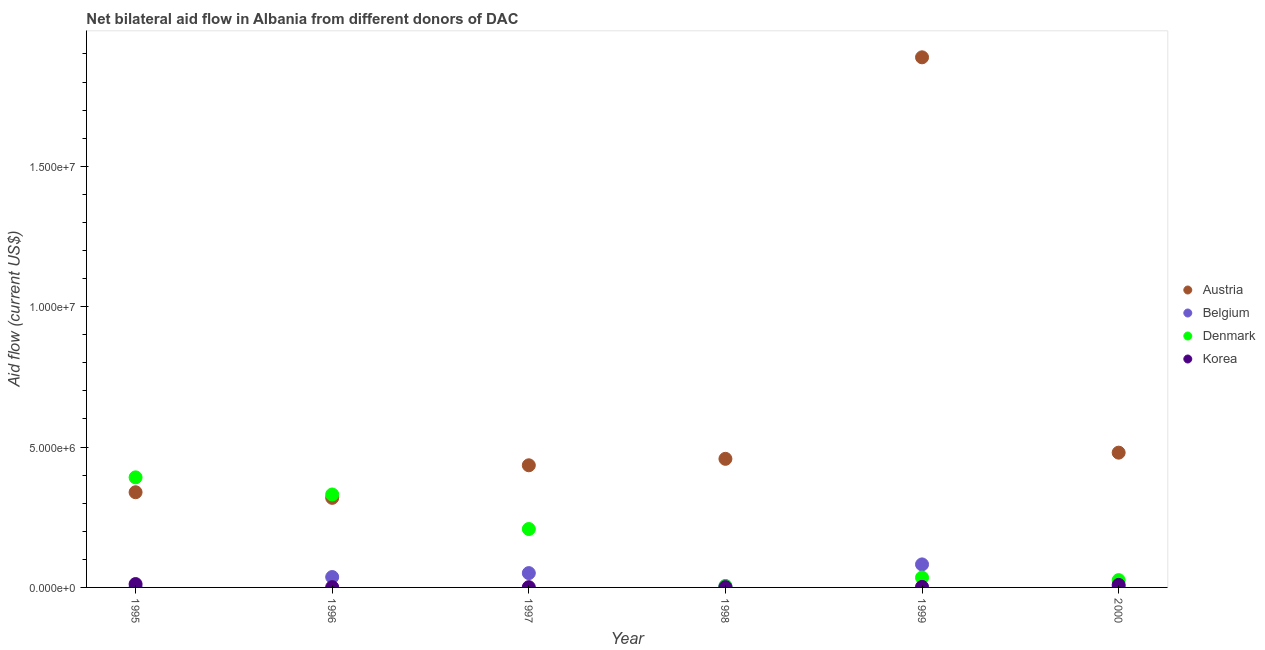Is the number of dotlines equal to the number of legend labels?
Keep it short and to the point. Yes. What is the amount of aid given by austria in 1996?
Your response must be concise. 3.19e+06. Across all years, what is the maximum amount of aid given by korea?
Your response must be concise. 1.20e+05. Across all years, what is the minimum amount of aid given by korea?
Keep it short and to the point. 10000. In which year was the amount of aid given by denmark minimum?
Your answer should be very brief. 1998. What is the total amount of aid given by denmark in the graph?
Keep it short and to the point. 9.95e+06. What is the difference between the amount of aid given by belgium in 1995 and that in 1996?
Provide a succinct answer. -3.60e+05. What is the difference between the amount of aid given by korea in 1998 and the amount of aid given by belgium in 1995?
Offer a terse response. 0. What is the average amount of aid given by denmark per year?
Offer a terse response. 1.66e+06. In the year 1997, what is the difference between the amount of aid given by austria and amount of aid given by belgium?
Offer a very short reply. 3.84e+06. In how many years, is the amount of aid given by austria greater than 8000000 US$?
Offer a terse response. 1. What is the ratio of the amount of aid given by korea in 1995 to that in 1999?
Ensure brevity in your answer.  6. What is the difference between the highest and the lowest amount of aid given by denmark?
Give a very brief answer. 3.89e+06. Is it the case that in every year, the sum of the amount of aid given by austria and amount of aid given by belgium is greater than the amount of aid given by denmark?
Make the answer very short. No. Does the amount of aid given by korea monotonically increase over the years?
Offer a very short reply. No. Is the amount of aid given by korea strictly less than the amount of aid given by belgium over the years?
Offer a terse response. No. How many dotlines are there?
Ensure brevity in your answer.  4. Does the graph contain any zero values?
Provide a succinct answer. No. Does the graph contain grids?
Provide a short and direct response. No. What is the title of the graph?
Your response must be concise. Net bilateral aid flow in Albania from different donors of DAC. What is the label or title of the Y-axis?
Offer a very short reply. Aid flow (current US$). What is the Aid flow (current US$) of Austria in 1995?
Ensure brevity in your answer.  3.39e+06. What is the Aid flow (current US$) in Denmark in 1995?
Offer a terse response. 3.92e+06. What is the Aid flow (current US$) of Korea in 1995?
Keep it short and to the point. 1.20e+05. What is the Aid flow (current US$) in Austria in 1996?
Provide a succinct answer. 3.19e+06. What is the Aid flow (current US$) in Belgium in 1996?
Provide a succinct answer. 3.70e+05. What is the Aid flow (current US$) of Denmark in 1996?
Ensure brevity in your answer.  3.31e+06. What is the Aid flow (current US$) in Austria in 1997?
Make the answer very short. 4.35e+06. What is the Aid flow (current US$) in Belgium in 1997?
Provide a short and direct response. 5.10e+05. What is the Aid flow (current US$) in Denmark in 1997?
Offer a very short reply. 2.08e+06. What is the Aid flow (current US$) of Austria in 1998?
Provide a succinct answer. 4.58e+06. What is the Aid flow (current US$) of Denmark in 1998?
Keep it short and to the point. 3.00e+04. What is the Aid flow (current US$) of Austria in 1999?
Ensure brevity in your answer.  1.89e+07. What is the Aid flow (current US$) in Belgium in 1999?
Keep it short and to the point. 8.20e+05. What is the Aid flow (current US$) of Denmark in 1999?
Give a very brief answer. 3.50e+05. What is the Aid flow (current US$) of Austria in 2000?
Give a very brief answer. 4.80e+06. What is the Aid flow (current US$) of Belgium in 2000?
Make the answer very short. 10000. Across all years, what is the maximum Aid flow (current US$) of Austria?
Your answer should be compact. 1.89e+07. Across all years, what is the maximum Aid flow (current US$) in Belgium?
Ensure brevity in your answer.  8.20e+05. Across all years, what is the maximum Aid flow (current US$) of Denmark?
Make the answer very short. 3.92e+06. Across all years, what is the maximum Aid flow (current US$) in Korea?
Ensure brevity in your answer.  1.20e+05. Across all years, what is the minimum Aid flow (current US$) of Austria?
Make the answer very short. 3.19e+06. Across all years, what is the minimum Aid flow (current US$) of Belgium?
Your answer should be compact. 10000. Across all years, what is the minimum Aid flow (current US$) of Denmark?
Make the answer very short. 3.00e+04. What is the total Aid flow (current US$) of Austria in the graph?
Provide a short and direct response. 3.92e+07. What is the total Aid flow (current US$) of Belgium in the graph?
Ensure brevity in your answer.  1.77e+06. What is the total Aid flow (current US$) in Denmark in the graph?
Make the answer very short. 9.95e+06. What is the total Aid flow (current US$) in Korea in the graph?
Offer a very short reply. 2.60e+05. What is the difference between the Aid flow (current US$) in Belgium in 1995 and that in 1996?
Your answer should be very brief. -3.60e+05. What is the difference between the Aid flow (current US$) in Denmark in 1995 and that in 1996?
Offer a terse response. 6.10e+05. What is the difference between the Aid flow (current US$) of Korea in 1995 and that in 1996?
Offer a very short reply. 1.10e+05. What is the difference between the Aid flow (current US$) of Austria in 1995 and that in 1997?
Offer a terse response. -9.60e+05. What is the difference between the Aid flow (current US$) in Belgium in 1995 and that in 1997?
Ensure brevity in your answer.  -5.00e+05. What is the difference between the Aid flow (current US$) in Denmark in 1995 and that in 1997?
Your answer should be compact. 1.84e+06. What is the difference between the Aid flow (current US$) in Korea in 1995 and that in 1997?
Your answer should be compact. 1.10e+05. What is the difference between the Aid flow (current US$) of Austria in 1995 and that in 1998?
Give a very brief answer. -1.19e+06. What is the difference between the Aid flow (current US$) in Denmark in 1995 and that in 1998?
Provide a short and direct response. 3.89e+06. What is the difference between the Aid flow (current US$) of Korea in 1995 and that in 1998?
Give a very brief answer. 1.10e+05. What is the difference between the Aid flow (current US$) of Austria in 1995 and that in 1999?
Your answer should be very brief. -1.55e+07. What is the difference between the Aid flow (current US$) of Belgium in 1995 and that in 1999?
Keep it short and to the point. -8.10e+05. What is the difference between the Aid flow (current US$) in Denmark in 1995 and that in 1999?
Provide a short and direct response. 3.57e+06. What is the difference between the Aid flow (current US$) of Korea in 1995 and that in 1999?
Offer a very short reply. 1.00e+05. What is the difference between the Aid flow (current US$) in Austria in 1995 and that in 2000?
Make the answer very short. -1.41e+06. What is the difference between the Aid flow (current US$) in Belgium in 1995 and that in 2000?
Make the answer very short. 0. What is the difference between the Aid flow (current US$) of Denmark in 1995 and that in 2000?
Give a very brief answer. 3.66e+06. What is the difference between the Aid flow (current US$) of Korea in 1995 and that in 2000?
Your answer should be very brief. 3.00e+04. What is the difference between the Aid flow (current US$) of Austria in 1996 and that in 1997?
Offer a terse response. -1.16e+06. What is the difference between the Aid flow (current US$) of Denmark in 1996 and that in 1997?
Your answer should be very brief. 1.23e+06. What is the difference between the Aid flow (current US$) of Korea in 1996 and that in 1997?
Ensure brevity in your answer.  0. What is the difference between the Aid flow (current US$) in Austria in 1996 and that in 1998?
Give a very brief answer. -1.39e+06. What is the difference between the Aid flow (current US$) of Denmark in 1996 and that in 1998?
Ensure brevity in your answer.  3.28e+06. What is the difference between the Aid flow (current US$) in Korea in 1996 and that in 1998?
Give a very brief answer. 0. What is the difference between the Aid flow (current US$) in Austria in 1996 and that in 1999?
Give a very brief answer. -1.57e+07. What is the difference between the Aid flow (current US$) in Belgium in 1996 and that in 1999?
Your answer should be compact. -4.50e+05. What is the difference between the Aid flow (current US$) of Denmark in 1996 and that in 1999?
Your answer should be compact. 2.96e+06. What is the difference between the Aid flow (current US$) of Korea in 1996 and that in 1999?
Provide a succinct answer. -10000. What is the difference between the Aid flow (current US$) of Austria in 1996 and that in 2000?
Provide a succinct answer. -1.61e+06. What is the difference between the Aid flow (current US$) of Denmark in 1996 and that in 2000?
Provide a short and direct response. 3.05e+06. What is the difference between the Aid flow (current US$) in Belgium in 1997 and that in 1998?
Your answer should be compact. 4.60e+05. What is the difference between the Aid flow (current US$) in Denmark in 1997 and that in 1998?
Provide a short and direct response. 2.05e+06. What is the difference between the Aid flow (current US$) in Austria in 1997 and that in 1999?
Offer a very short reply. -1.45e+07. What is the difference between the Aid flow (current US$) in Belgium in 1997 and that in 1999?
Ensure brevity in your answer.  -3.10e+05. What is the difference between the Aid flow (current US$) of Denmark in 1997 and that in 1999?
Keep it short and to the point. 1.73e+06. What is the difference between the Aid flow (current US$) of Austria in 1997 and that in 2000?
Offer a very short reply. -4.50e+05. What is the difference between the Aid flow (current US$) of Belgium in 1997 and that in 2000?
Your answer should be compact. 5.00e+05. What is the difference between the Aid flow (current US$) of Denmark in 1997 and that in 2000?
Make the answer very short. 1.82e+06. What is the difference between the Aid flow (current US$) of Korea in 1997 and that in 2000?
Give a very brief answer. -8.00e+04. What is the difference between the Aid flow (current US$) in Austria in 1998 and that in 1999?
Ensure brevity in your answer.  -1.43e+07. What is the difference between the Aid flow (current US$) of Belgium in 1998 and that in 1999?
Provide a succinct answer. -7.70e+05. What is the difference between the Aid flow (current US$) of Denmark in 1998 and that in 1999?
Offer a terse response. -3.20e+05. What is the difference between the Aid flow (current US$) of Korea in 1998 and that in 1999?
Your answer should be compact. -10000. What is the difference between the Aid flow (current US$) in Austria in 1999 and that in 2000?
Make the answer very short. 1.41e+07. What is the difference between the Aid flow (current US$) in Belgium in 1999 and that in 2000?
Make the answer very short. 8.10e+05. What is the difference between the Aid flow (current US$) in Korea in 1999 and that in 2000?
Offer a very short reply. -7.00e+04. What is the difference between the Aid flow (current US$) in Austria in 1995 and the Aid flow (current US$) in Belgium in 1996?
Your answer should be compact. 3.02e+06. What is the difference between the Aid flow (current US$) in Austria in 1995 and the Aid flow (current US$) in Denmark in 1996?
Your response must be concise. 8.00e+04. What is the difference between the Aid flow (current US$) in Austria in 1995 and the Aid flow (current US$) in Korea in 1996?
Make the answer very short. 3.38e+06. What is the difference between the Aid flow (current US$) in Belgium in 1995 and the Aid flow (current US$) in Denmark in 1996?
Your answer should be compact. -3.30e+06. What is the difference between the Aid flow (current US$) of Belgium in 1995 and the Aid flow (current US$) of Korea in 1996?
Give a very brief answer. 0. What is the difference between the Aid flow (current US$) of Denmark in 1995 and the Aid flow (current US$) of Korea in 1996?
Your answer should be very brief. 3.91e+06. What is the difference between the Aid flow (current US$) in Austria in 1995 and the Aid flow (current US$) in Belgium in 1997?
Offer a terse response. 2.88e+06. What is the difference between the Aid flow (current US$) of Austria in 1995 and the Aid flow (current US$) of Denmark in 1997?
Make the answer very short. 1.31e+06. What is the difference between the Aid flow (current US$) in Austria in 1995 and the Aid flow (current US$) in Korea in 1997?
Offer a very short reply. 3.38e+06. What is the difference between the Aid flow (current US$) in Belgium in 1995 and the Aid flow (current US$) in Denmark in 1997?
Provide a short and direct response. -2.07e+06. What is the difference between the Aid flow (current US$) of Denmark in 1995 and the Aid flow (current US$) of Korea in 1997?
Provide a short and direct response. 3.91e+06. What is the difference between the Aid flow (current US$) of Austria in 1995 and the Aid flow (current US$) of Belgium in 1998?
Your response must be concise. 3.34e+06. What is the difference between the Aid flow (current US$) in Austria in 1995 and the Aid flow (current US$) in Denmark in 1998?
Make the answer very short. 3.36e+06. What is the difference between the Aid flow (current US$) in Austria in 1995 and the Aid flow (current US$) in Korea in 1998?
Provide a succinct answer. 3.38e+06. What is the difference between the Aid flow (current US$) of Belgium in 1995 and the Aid flow (current US$) of Korea in 1998?
Keep it short and to the point. 0. What is the difference between the Aid flow (current US$) of Denmark in 1995 and the Aid flow (current US$) of Korea in 1998?
Your response must be concise. 3.91e+06. What is the difference between the Aid flow (current US$) in Austria in 1995 and the Aid flow (current US$) in Belgium in 1999?
Your answer should be very brief. 2.57e+06. What is the difference between the Aid flow (current US$) of Austria in 1995 and the Aid flow (current US$) of Denmark in 1999?
Your answer should be very brief. 3.04e+06. What is the difference between the Aid flow (current US$) of Austria in 1995 and the Aid flow (current US$) of Korea in 1999?
Keep it short and to the point. 3.37e+06. What is the difference between the Aid flow (current US$) of Belgium in 1995 and the Aid flow (current US$) of Denmark in 1999?
Keep it short and to the point. -3.40e+05. What is the difference between the Aid flow (current US$) of Denmark in 1995 and the Aid flow (current US$) of Korea in 1999?
Make the answer very short. 3.90e+06. What is the difference between the Aid flow (current US$) of Austria in 1995 and the Aid flow (current US$) of Belgium in 2000?
Ensure brevity in your answer.  3.38e+06. What is the difference between the Aid flow (current US$) in Austria in 1995 and the Aid flow (current US$) in Denmark in 2000?
Your response must be concise. 3.13e+06. What is the difference between the Aid flow (current US$) of Austria in 1995 and the Aid flow (current US$) of Korea in 2000?
Your answer should be very brief. 3.30e+06. What is the difference between the Aid flow (current US$) of Denmark in 1995 and the Aid flow (current US$) of Korea in 2000?
Ensure brevity in your answer.  3.83e+06. What is the difference between the Aid flow (current US$) in Austria in 1996 and the Aid flow (current US$) in Belgium in 1997?
Provide a succinct answer. 2.68e+06. What is the difference between the Aid flow (current US$) in Austria in 1996 and the Aid flow (current US$) in Denmark in 1997?
Your response must be concise. 1.11e+06. What is the difference between the Aid flow (current US$) in Austria in 1996 and the Aid flow (current US$) in Korea in 1997?
Make the answer very short. 3.18e+06. What is the difference between the Aid flow (current US$) of Belgium in 1996 and the Aid flow (current US$) of Denmark in 1997?
Provide a succinct answer. -1.71e+06. What is the difference between the Aid flow (current US$) in Belgium in 1996 and the Aid flow (current US$) in Korea in 1997?
Provide a succinct answer. 3.60e+05. What is the difference between the Aid flow (current US$) of Denmark in 1996 and the Aid flow (current US$) of Korea in 1997?
Your answer should be compact. 3.30e+06. What is the difference between the Aid flow (current US$) in Austria in 1996 and the Aid flow (current US$) in Belgium in 1998?
Ensure brevity in your answer.  3.14e+06. What is the difference between the Aid flow (current US$) in Austria in 1996 and the Aid flow (current US$) in Denmark in 1998?
Your answer should be very brief. 3.16e+06. What is the difference between the Aid flow (current US$) in Austria in 1996 and the Aid flow (current US$) in Korea in 1998?
Your response must be concise. 3.18e+06. What is the difference between the Aid flow (current US$) of Denmark in 1996 and the Aid flow (current US$) of Korea in 1998?
Provide a short and direct response. 3.30e+06. What is the difference between the Aid flow (current US$) in Austria in 1996 and the Aid flow (current US$) in Belgium in 1999?
Your answer should be very brief. 2.37e+06. What is the difference between the Aid flow (current US$) in Austria in 1996 and the Aid flow (current US$) in Denmark in 1999?
Ensure brevity in your answer.  2.84e+06. What is the difference between the Aid flow (current US$) of Austria in 1996 and the Aid flow (current US$) of Korea in 1999?
Keep it short and to the point. 3.17e+06. What is the difference between the Aid flow (current US$) of Belgium in 1996 and the Aid flow (current US$) of Denmark in 1999?
Offer a terse response. 2.00e+04. What is the difference between the Aid flow (current US$) of Denmark in 1996 and the Aid flow (current US$) of Korea in 1999?
Provide a succinct answer. 3.29e+06. What is the difference between the Aid flow (current US$) of Austria in 1996 and the Aid flow (current US$) of Belgium in 2000?
Your answer should be very brief. 3.18e+06. What is the difference between the Aid flow (current US$) in Austria in 1996 and the Aid flow (current US$) in Denmark in 2000?
Keep it short and to the point. 2.93e+06. What is the difference between the Aid flow (current US$) in Austria in 1996 and the Aid flow (current US$) in Korea in 2000?
Your response must be concise. 3.10e+06. What is the difference between the Aid flow (current US$) in Belgium in 1996 and the Aid flow (current US$) in Korea in 2000?
Provide a succinct answer. 2.80e+05. What is the difference between the Aid flow (current US$) in Denmark in 1996 and the Aid flow (current US$) in Korea in 2000?
Your answer should be very brief. 3.22e+06. What is the difference between the Aid flow (current US$) in Austria in 1997 and the Aid flow (current US$) in Belgium in 1998?
Your answer should be very brief. 4.30e+06. What is the difference between the Aid flow (current US$) in Austria in 1997 and the Aid flow (current US$) in Denmark in 1998?
Give a very brief answer. 4.32e+06. What is the difference between the Aid flow (current US$) of Austria in 1997 and the Aid flow (current US$) of Korea in 1998?
Your response must be concise. 4.34e+06. What is the difference between the Aid flow (current US$) of Denmark in 1997 and the Aid flow (current US$) of Korea in 1998?
Your answer should be compact. 2.07e+06. What is the difference between the Aid flow (current US$) of Austria in 1997 and the Aid flow (current US$) of Belgium in 1999?
Your response must be concise. 3.53e+06. What is the difference between the Aid flow (current US$) of Austria in 1997 and the Aid flow (current US$) of Denmark in 1999?
Your answer should be compact. 4.00e+06. What is the difference between the Aid flow (current US$) of Austria in 1997 and the Aid flow (current US$) of Korea in 1999?
Offer a very short reply. 4.33e+06. What is the difference between the Aid flow (current US$) of Belgium in 1997 and the Aid flow (current US$) of Denmark in 1999?
Give a very brief answer. 1.60e+05. What is the difference between the Aid flow (current US$) of Denmark in 1997 and the Aid flow (current US$) of Korea in 1999?
Provide a succinct answer. 2.06e+06. What is the difference between the Aid flow (current US$) in Austria in 1997 and the Aid flow (current US$) in Belgium in 2000?
Your response must be concise. 4.34e+06. What is the difference between the Aid flow (current US$) of Austria in 1997 and the Aid flow (current US$) of Denmark in 2000?
Keep it short and to the point. 4.09e+06. What is the difference between the Aid flow (current US$) of Austria in 1997 and the Aid flow (current US$) of Korea in 2000?
Keep it short and to the point. 4.26e+06. What is the difference between the Aid flow (current US$) in Belgium in 1997 and the Aid flow (current US$) in Denmark in 2000?
Offer a very short reply. 2.50e+05. What is the difference between the Aid flow (current US$) in Belgium in 1997 and the Aid flow (current US$) in Korea in 2000?
Make the answer very short. 4.20e+05. What is the difference between the Aid flow (current US$) in Denmark in 1997 and the Aid flow (current US$) in Korea in 2000?
Ensure brevity in your answer.  1.99e+06. What is the difference between the Aid flow (current US$) of Austria in 1998 and the Aid flow (current US$) of Belgium in 1999?
Your answer should be compact. 3.76e+06. What is the difference between the Aid flow (current US$) in Austria in 1998 and the Aid flow (current US$) in Denmark in 1999?
Provide a short and direct response. 4.23e+06. What is the difference between the Aid flow (current US$) in Austria in 1998 and the Aid flow (current US$) in Korea in 1999?
Your answer should be very brief. 4.56e+06. What is the difference between the Aid flow (current US$) of Denmark in 1998 and the Aid flow (current US$) of Korea in 1999?
Keep it short and to the point. 10000. What is the difference between the Aid flow (current US$) in Austria in 1998 and the Aid flow (current US$) in Belgium in 2000?
Offer a terse response. 4.57e+06. What is the difference between the Aid flow (current US$) of Austria in 1998 and the Aid flow (current US$) of Denmark in 2000?
Give a very brief answer. 4.32e+06. What is the difference between the Aid flow (current US$) in Austria in 1998 and the Aid flow (current US$) in Korea in 2000?
Offer a very short reply. 4.49e+06. What is the difference between the Aid flow (current US$) of Belgium in 1998 and the Aid flow (current US$) of Denmark in 2000?
Keep it short and to the point. -2.10e+05. What is the difference between the Aid flow (current US$) in Belgium in 1998 and the Aid flow (current US$) in Korea in 2000?
Your answer should be compact. -4.00e+04. What is the difference between the Aid flow (current US$) in Austria in 1999 and the Aid flow (current US$) in Belgium in 2000?
Your response must be concise. 1.89e+07. What is the difference between the Aid flow (current US$) of Austria in 1999 and the Aid flow (current US$) of Denmark in 2000?
Give a very brief answer. 1.86e+07. What is the difference between the Aid flow (current US$) in Austria in 1999 and the Aid flow (current US$) in Korea in 2000?
Make the answer very short. 1.88e+07. What is the difference between the Aid flow (current US$) of Belgium in 1999 and the Aid flow (current US$) of Denmark in 2000?
Give a very brief answer. 5.60e+05. What is the difference between the Aid flow (current US$) of Belgium in 1999 and the Aid flow (current US$) of Korea in 2000?
Your answer should be very brief. 7.30e+05. What is the difference between the Aid flow (current US$) in Denmark in 1999 and the Aid flow (current US$) in Korea in 2000?
Give a very brief answer. 2.60e+05. What is the average Aid flow (current US$) in Austria per year?
Make the answer very short. 6.53e+06. What is the average Aid flow (current US$) of Belgium per year?
Provide a short and direct response. 2.95e+05. What is the average Aid flow (current US$) of Denmark per year?
Your response must be concise. 1.66e+06. What is the average Aid flow (current US$) in Korea per year?
Your response must be concise. 4.33e+04. In the year 1995, what is the difference between the Aid flow (current US$) of Austria and Aid flow (current US$) of Belgium?
Provide a succinct answer. 3.38e+06. In the year 1995, what is the difference between the Aid flow (current US$) in Austria and Aid flow (current US$) in Denmark?
Your answer should be compact. -5.30e+05. In the year 1995, what is the difference between the Aid flow (current US$) in Austria and Aid flow (current US$) in Korea?
Your response must be concise. 3.27e+06. In the year 1995, what is the difference between the Aid flow (current US$) in Belgium and Aid flow (current US$) in Denmark?
Provide a short and direct response. -3.91e+06. In the year 1995, what is the difference between the Aid flow (current US$) of Belgium and Aid flow (current US$) of Korea?
Give a very brief answer. -1.10e+05. In the year 1995, what is the difference between the Aid flow (current US$) in Denmark and Aid flow (current US$) in Korea?
Your response must be concise. 3.80e+06. In the year 1996, what is the difference between the Aid flow (current US$) of Austria and Aid flow (current US$) of Belgium?
Keep it short and to the point. 2.82e+06. In the year 1996, what is the difference between the Aid flow (current US$) of Austria and Aid flow (current US$) of Korea?
Keep it short and to the point. 3.18e+06. In the year 1996, what is the difference between the Aid flow (current US$) of Belgium and Aid flow (current US$) of Denmark?
Provide a short and direct response. -2.94e+06. In the year 1996, what is the difference between the Aid flow (current US$) in Belgium and Aid flow (current US$) in Korea?
Your answer should be compact. 3.60e+05. In the year 1996, what is the difference between the Aid flow (current US$) of Denmark and Aid flow (current US$) of Korea?
Your answer should be compact. 3.30e+06. In the year 1997, what is the difference between the Aid flow (current US$) in Austria and Aid flow (current US$) in Belgium?
Provide a short and direct response. 3.84e+06. In the year 1997, what is the difference between the Aid flow (current US$) of Austria and Aid flow (current US$) of Denmark?
Your answer should be compact. 2.27e+06. In the year 1997, what is the difference between the Aid flow (current US$) of Austria and Aid flow (current US$) of Korea?
Keep it short and to the point. 4.34e+06. In the year 1997, what is the difference between the Aid flow (current US$) in Belgium and Aid flow (current US$) in Denmark?
Your answer should be very brief. -1.57e+06. In the year 1997, what is the difference between the Aid flow (current US$) in Denmark and Aid flow (current US$) in Korea?
Your response must be concise. 2.07e+06. In the year 1998, what is the difference between the Aid flow (current US$) in Austria and Aid flow (current US$) in Belgium?
Provide a short and direct response. 4.53e+06. In the year 1998, what is the difference between the Aid flow (current US$) of Austria and Aid flow (current US$) of Denmark?
Make the answer very short. 4.55e+06. In the year 1998, what is the difference between the Aid flow (current US$) of Austria and Aid flow (current US$) of Korea?
Give a very brief answer. 4.57e+06. In the year 1998, what is the difference between the Aid flow (current US$) in Belgium and Aid flow (current US$) in Denmark?
Your response must be concise. 2.00e+04. In the year 1998, what is the difference between the Aid flow (current US$) of Belgium and Aid flow (current US$) of Korea?
Your answer should be compact. 4.00e+04. In the year 1998, what is the difference between the Aid flow (current US$) of Denmark and Aid flow (current US$) of Korea?
Your response must be concise. 2.00e+04. In the year 1999, what is the difference between the Aid flow (current US$) of Austria and Aid flow (current US$) of Belgium?
Your answer should be compact. 1.81e+07. In the year 1999, what is the difference between the Aid flow (current US$) of Austria and Aid flow (current US$) of Denmark?
Offer a very short reply. 1.85e+07. In the year 1999, what is the difference between the Aid flow (current US$) of Austria and Aid flow (current US$) of Korea?
Ensure brevity in your answer.  1.89e+07. In the year 1999, what is the difference between the Aid flow (current US$) of Belgium and Aid flow (current US$) of Denmark?
Ensure brevity in your answer.  4.70e+05. In the year 1999, what is the difference between the Aid flow (current US$) of Denmark and Aid flow (current US$) of Korea?
Make the answer very short. 3.30e+05. In the year 2000, what is the difference between the Aid flow (current US$) in Austria and Aid flow (current US$) in Belgium?
Keep it short and to the point. 4.79e+06. In the year 2000, what is the difference between the Aid flow (current US$) of Austria and Aid flow (current US$) of Denmark?
Offer a very short reply. 4.54e+06. In the year 2000, what is the difference between the Aid flow (current US$) of Austria and Aid flow (current US$) of Korea?
Provide a short and direct response. 4.71e+06. In the year 2000, what is the difference between the Aid flow (current US$) of Denmark and Aid flow (current US$) of Korea?
Offer a very short reply. 1.70e+05. What is the ratio of the Aid flow (current US$) in Austria in 1995 to that in 1996?
Provide a short and direct response. 1.06. What is the ratio of the Aid flow (current US$) in Belgium in 1995 to that in 1996?
Ensure brevity in your answer.  0.03. What is the ratio of the Aid flow (current US$) of Denmark in 1995 to that in 1996?
Ensure brevity in your answer.  1.18. What is the ratio of the Aid flow (current US$) of Korea in 1995 to that in 1996?
Your response must be concise. 12. What is the ratio of the Aid flow (current US$) of Austria in 1995 to that in 1997?
Your answer should be very brief. 0.78. What is the ratio of the Aid flow (current US$) of Belgium in 1995 to that in 1997?
Your response must be concise. 0.02. What is the ratio of the Aid flow (current US$) in Denmark in 1995 to that in 1997?
Make the answer very short. 1.88. What is the ratio of the Aid flow (current US$) of Austria in 1995 to that in 1998?
Make the answer very short. 0.74. What is the ratio of the Aid flow (current US$) in Belgium in 1995 to that in 1998?
Make the answer very short. 0.2. What is the ratio of the Aid flow (current US$) of Denmark in 1995 to that in 1998?
Offer a terse response. 130.67. What is the ratio of the Aid flow (current US$) of Korea in 1995 to that in 1998?
Provide a short and direct response. 12. What is the ratio of the Aid flow (current US$) of Austria in 1995 to that in 1999?
Your answer should be very brief. 0.18. What is the ratio of the Aid flow (current US$) of Belgium in 1995 to that in 1999?
Provide a short and direct response. 0.01. What is the ratio of the Aid flow (current US$) of Denmark in 1995 to that in 1999?
Give a very brief answer. 11.2. What is the ratio of the Aid flow (current US$) of Korea in 1995 to that in 1999?
Keep it short and to the point. 6. What is the ratio of the Aid flow (current US$) in Austria in 1995 to that in 2000?
Provide a succinct answer. 0.71. What is the ratio of the Aid flow (current US$) in Belgium in 1995 to that in 2000?
Ensure brevity in your answer.  1. What is the ratio of the Aid flow (current US$) of Denmark in 1995 to that in 2000?
Offer a very short reply. 15.08. What is the ratio of the Aid flow (current US$) in Austria in 1996 to that in 1997?
Provide a short and direct response. 0.73. What is the ratio of the Aid flow (current US$) in Belgium in 1996 to that in 1997?
Make the answer very short. 0.73. What is the ratio of the Aid flow (current US$) of Denmark in 1996 to that in 1997?
Keep it short and to the point. 1.59. What is the ratio of the Aid flow (current US$) of Korea in 1996 to that in 1997?
Offer a terse response. 1. What is the ratio of the Aid flow (current US$) in Austria in 1996 to that in 1998?
Your answer should be very brief. 0.7. What is the ratio of the Aid flow (current US$) in Denmark in 1996 to that in 1998?
Offer a very short reply. 110.33. What is the ratio of the Aid flow (current US$) in Korea in 1996 to that in 1998?
Ensure brevity in your answer.  1. What is the ratio of the Aid flow (current US$) in Austria in 1996 to that in 1999?
Your response must be concise. 0.17. What is the ratio of the Aid flow (current US$) of Belgium in 1996 to that in 1999?
Provide a succinct answer. 0.45. What is the ratio of the Aid flow (current US$) in Denmark in 1996 to that in 1999?
Keep it short and to the point. 9.46. What is the ratio of the Aid flow (current US$) of Korea in 1996 to that in 1999?
Offer a terse response. 0.5. What is the ratio of the Aid flow (current US$) of Austria in 1996 to that in 2000?
Your answer should be very brief. 0.66. What is the ratio of the Aid flow (current US$) of Belgium in 1996 to that in 2000?
Provide a short and direct response. 37. What is the ratio of the Aid flow (current US$) in Denmark in 1996 to that in 2000?
Provide a short and direct response. 12.73. What is the ratio of the Aid flow (current US$) in Austria in 1997 to that in 1998?
Your response must be concise. 0.95. What is the ratio of the Aid flow (current US$) in Denmark in 1997 to that in 1998?
Provide a short and direct response. 69.33. What is the ratio of the Aid flow (current US$) in Austria in 1997 to that in 1999?
Your answer should be compact. 0.23. What is the ratio of the Aid flow (current US$) in Belgium in 1997 to that in 1999?
Provide a short and direct response. 0.62. What is the ratio of the Aid flow (current US$) in Denmark in 1997 to that in 1999?
Ensure brevity in your answer.  5.94. What is the ratio of the Aid flow (current US$) of Austria in 1997 to that in 2000?
Your response must be concise. 0.91. What is the ratio of the Aid flow (current US$) of Denmark in 1997 to that in 2000?
Your answer should be very brief. 8. What is the ratio of the Aid flow (current US$) of Austria in 1998 to that in 1999?
Your answer should be compact. 0.24. What is the ratio of the Aid flow (current US$) of Belgium in 1998 to that in 1999?
Your answer should be very brief. 0.06. What is the ratio of the Aid flow (current US$) of Denmark in 1998 to that in 1999?
Give a very brief answer. 0.09. What is the ratio of the Aid flow (current US$) in Korea in 1998 to that in 1999?
Your answer should be compact. 0.5. What is the ratio of the Aid flow (current US$) in Austria in 1998 to that in 2000?
Give a very brief answer. 0.95. What is the ratio of the Aid flow (current US$) of Denmark in 1998 to that in 2000?
Provide a succinct answer. 0.12. What is the ratio of the Aid flow (current US$) of Austria in 1999 to that in 2000?
Offer a very short reply. 3.93. What is the ratio of the Aid flow (current US$) of Denmark in 1999 to that in 2000?
Offer a terse response. 1.35. What is the ratio of the Aid flow (current US$) of Korea in 1999 to that in 2000?
Your answer should be compact. 0.22. What is the difference between the highest and the second highest Aid flow (current US$) in Austria?
Offer a very short reply. 1.41e+07. What is the difference between the highest and the second highest Aid flow (current US$) in Denmark?
Make the answer very short. 6.10e+05. What is the difference between the highest and the second highest Aid flow (current US$) of Korea?
Offer a very short reply. 3.00e+04. What is the difference between the highest and the lowest Aid flow (current US$) in Austria?
Make the answer very short. 1.57e+07. What is the difference between the highest and the lowest Aid flow (current US$) of Belgium?
Offer a very short reply. 8.10e+05. What is the difference between the highest and the lowest Aid flow (current US$) of Denmark?
Your answer should be very brief. 3.89e+06. 